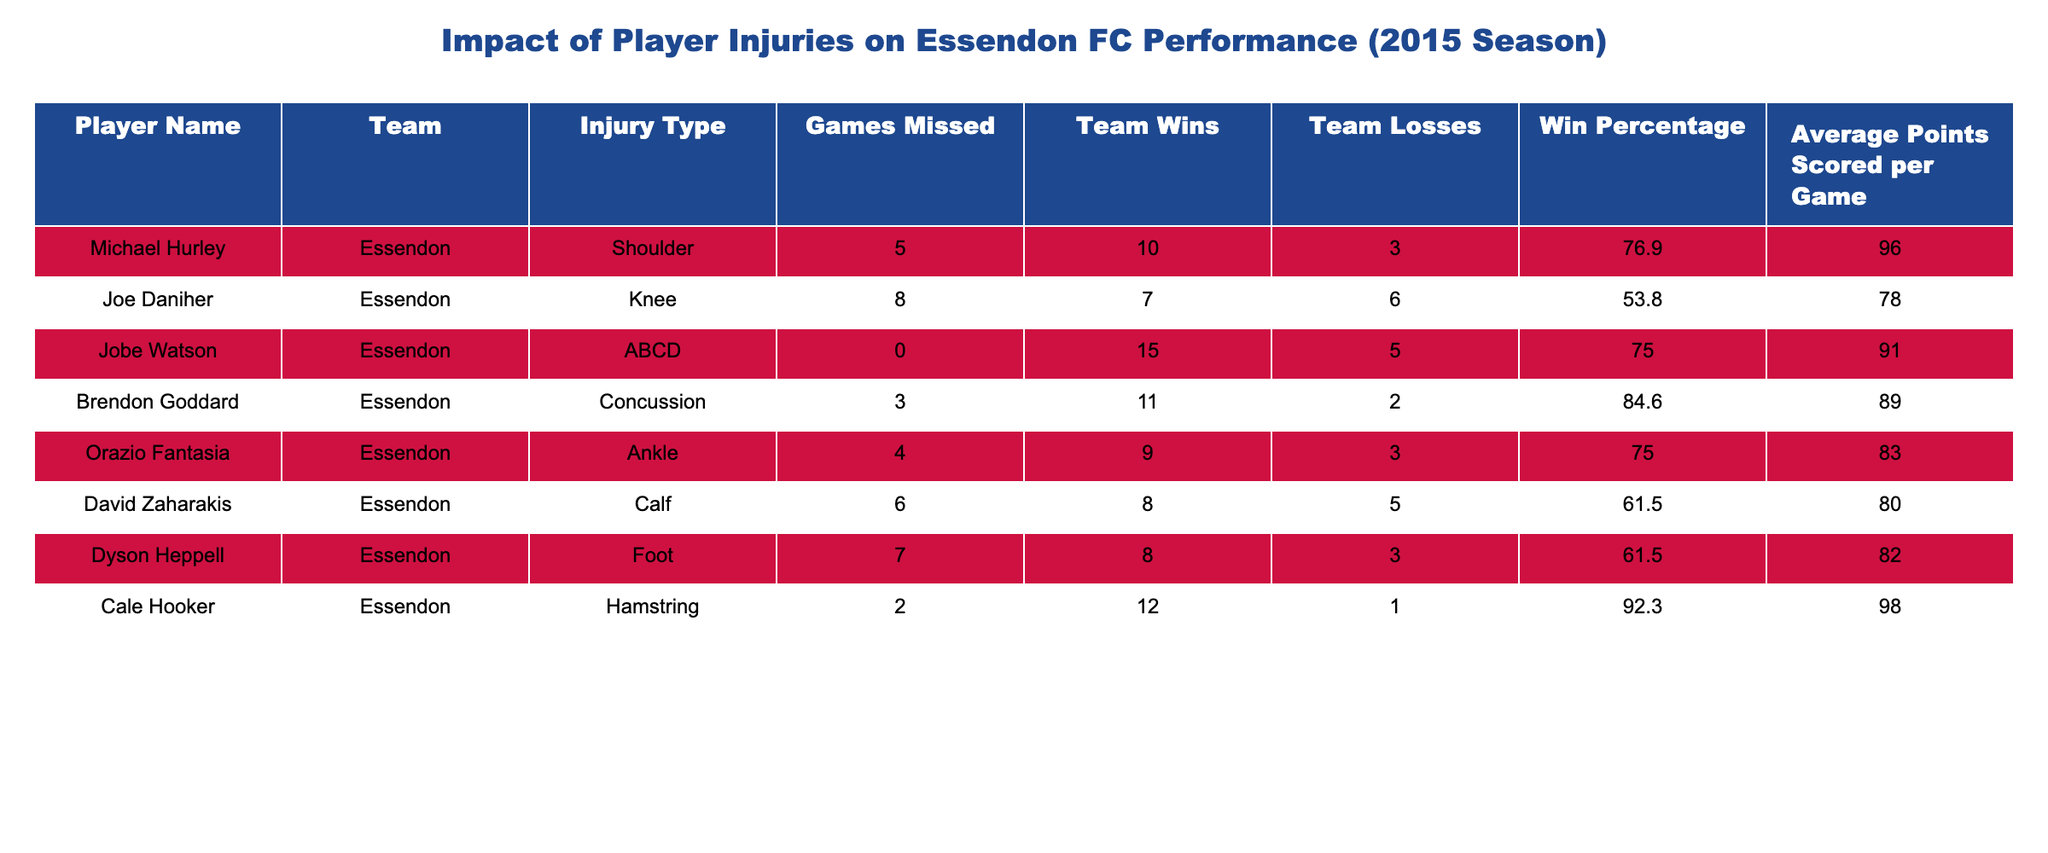What is the injury type of Joe Daniher? Joe Daniher is listed under the "Injury Type" column, where his entry shows "Knee."
Answer: Knee How many games did Michael Hurley miss due to his injury? In the "Games Missed" column, Michael Hurley's entry indicates that he missed 5 games.
Answer: 5 What is the win percentage of the team when Jobe Watson played? Jobe Watson's entry shows a win percentage of 75.0 in the "Win Percentage" column, indicating that the team had a successful season while he was on the field.
Answer: 75.0 What is the total number of games missed by all players listed in the table? Summing the "Games Missed" values: 5 (Hurley) + 8 (Daniher) + 0 (Watson) + 3 (Goddard) + 4 (Fantasia) + 6 (Zaharakis) + 7 (Heppell) + 2 (Hooker) equals 35.
Answer: 35 Does David Zaharakis have a higher win percentage than Dyson Heppell? David Zaharakis' win percentage is 61.5, while Dyson Heppell's is also 61.5. Since they are equal, the answer is no.
Answer: No Which player had the highest average points scored per game? Examining the "Average Points Scored per Game" column, Cale Hooker scored 98 points per game, the highest among the players listed.
Answer: 98 How many losses did the team experience while Joe Daniher was injured? Joe Daniher's entry reveals that the team had 6 losses during the 8 games he missed due to his knee injury.
Answer: 6 What is the average number of games missed by the players listed in the table? To find the average, sum the "Games Missed" (5 + 8 + 0 + 3 + 4 + 6 + 7 + 2 = 35) and divide by the number of players (8): 35 / 8 equals 4.375.
Answer: 4.375 Was Brendon Goddard's injury more impactful on team performance than Michael Hurley's in terms of games missed? Brendon Goddard missed 3 games while Michael Hurley missed 5 games, therefore Hurley's injury was more impactful in terms of games missed.
Answer: Yes How many total wins did the Essendon team achieve with the injured players listed? Adding the "Team Wins" for all players: 10 (Hurley) + 7 (Daniher) + 15 (Watson) + 11 (Goddard) + 9 (Fantasia) + 8 (Zaharakis) + 8 (Heppell) + 12 (Hooker) totals to 80 wins.
Answer: 80 